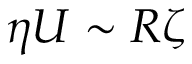<formula> <loc_0><loc_0><loc_500><loc_500>\eta U \sim R \zeta</formula> 